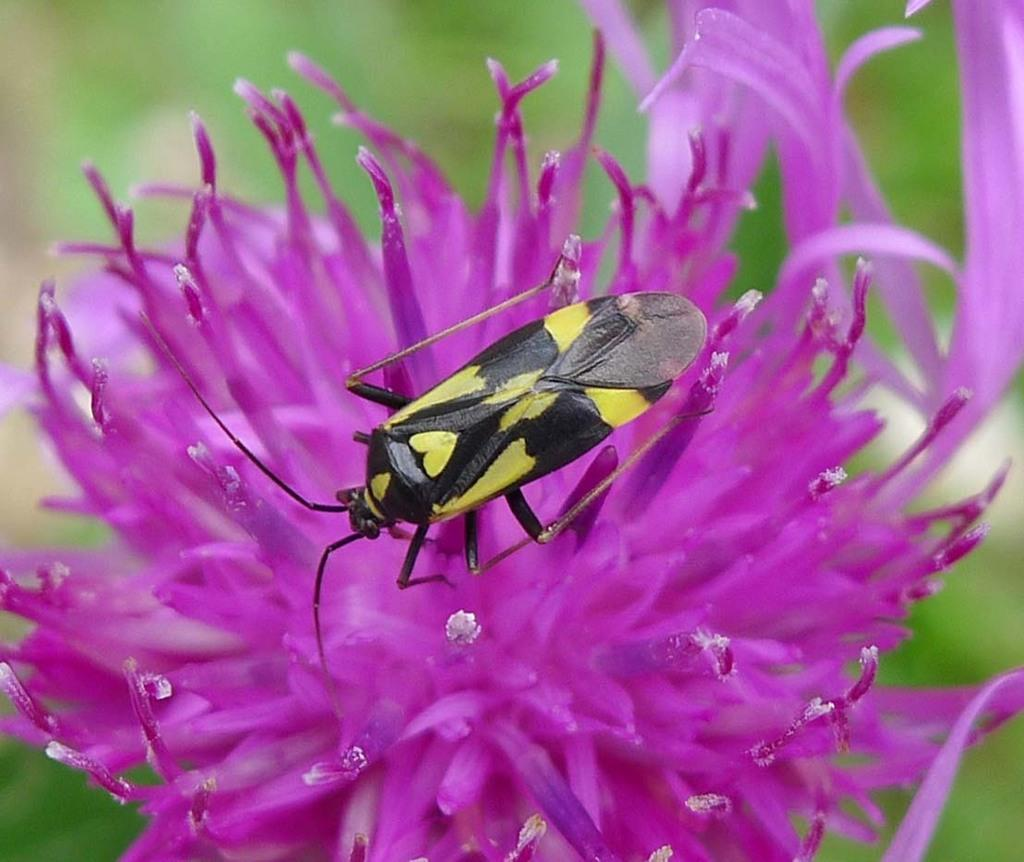What is present in the image along with the flower? There is an insect in the image. What color is the flower that the insect is on? The flower is purple. How would you describe the background of the image? The background of the image is blurred. What type of pear is being eaten by the insect in the image? There is no pear present in the image; the insect is on a purple flower. What action is the insect performing on the lip in the image? There is no lip present in the image; the insect is on a purple flower. 